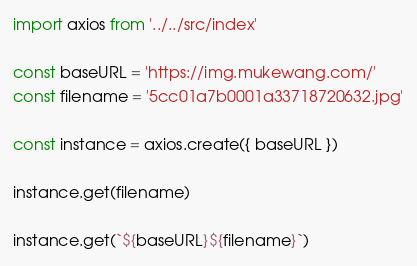Convert code to text. <code><loc_0><loc_0><loc_500><loc_500><_TypeScript_>import axios from '../../src/index'

const baseURL = 'https://img.mukewang.com/'
const filename = '5cc01a7b0001a33718720632.jpg'

const instance = axios.create({ baseURL })

instance.get(filename)

instance.get(`${baseURL}${filename}`)
</code> 